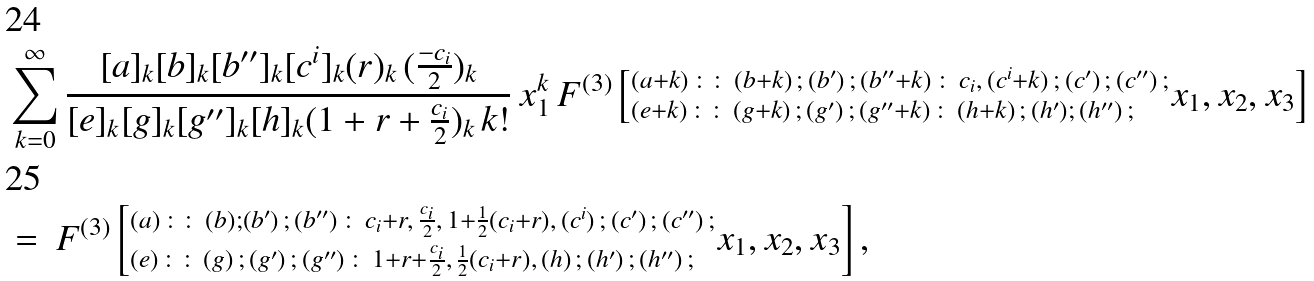Convert formula to latex. <formula><loc_0><loc_0><loc_500><loc_500>& \sum _ { k = 0 } ^ { \infty } \frac { [ a ] _ { k } [ b ] _ { k } [ b ^ { \prime \prime } ] _ { k } [ c ^ { i } ] _ { k } ( r ) _ { k } \, ( \frac { - c _ { i } } { 2 } ) _ { k } } { [ e ] _ { k } [ g ] _ { k } [ g ^ { \prime \prime } ] _ { k } [ h ] _ { k } ( 1 + r + \frac { c _ { i } } { 2 } ) _ { k } \, k ! } \, x _ { 1 } ^ { k } \, F ^ { ( 3 ) } \left [ ^ { ( a + k ) \, \colon \colon \, ( b + k ) \, ; \, ( b ^ { \prime } ) \, ; \, ( b ^ { \prime \prime } + k ) \, \colon \, c _ { i } , \, ( c ^ { i } + k ) \, ; \, ( c ^ { \prime } ) \, ; \, ( c ^ { \prime \prime } ) \, ; } _ { ( e + k ) \, \colon \colon \, ( g + k ) \, ; \, ( g ^ { \prime } ) \, ; \, ( g ^ { \prime \prime } + k ) \, \colon \, ( h + k ) \, ; \, ( h ^ { \prime } ) ; \, ( h ^ { \prime \prime } ) \, ; } x _ { 1 } , x _ { 2 } , x _ { 3 } \right ] \\ & = \, F ^ { ( 3 ) } \left [ ^ { ( a ) \, \colon \colon \, ( b ) ; ( b ^ { \prime } ) \, ; \, ( b ^ { \prime \prime } ) \, \colon \, c _ { i } + r , \, \frac { c _ { i } } { 2 } , \, 1 + \frac { 1 } { 2 } ( c _ { i } + r ) , \, ( c ^ { i } ) \, ; \, ( c ^ { \prime } ) \, ; \, ( c ^ { \prime \prime } ) \, ; } _ { ( e ) \, \colon \colon \, ( g ) \, ; \, ( g ^ { \prime } ) \, ; \, ( g ^ { \prime \prime } ) \, \colon \, 1 + r + \frac { c _ { i } } { 2 } , \, \frac { 1 } { 2 } ( c _ { i } + r ) , \, ( h ) \, ; \, ( h ^ { \prime } ) \, ; \, ( h ^ { \prime \prime } ) \, ; } x _ { 1 } , x _ { 2 } , x _ { 3 } \right ] ,</formula> 